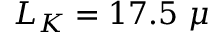Convert formula to latex. <formula><loc_0><loc_0><loc_500><loc_500>L _ { K } = 1 7 . 5 \mu</formula> 